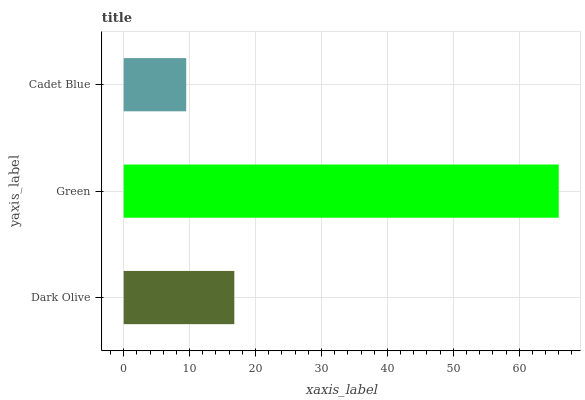Is Cadet Blue the minimum?
Answer yes or no. Yes. Is Green the maximum?
Answer yes or no. Yes. Is Green the minimum?
Answer yes or no. No. Is Cadet Blue the maximum?
Answer yes or no. No. Is Green greater than Cadet Blue?
Answer yes or no. Yes. Is Cadet Blue less than Green?
Answer yes or no. Yes. Is Cadet Blue greater than Green?
Answer yes or no. No. Is Green less than Cadet Blue?
Answer yes or no. No. Is Dark Olive the high median?
Answer yes or no. Yes. Is Dark Olive the low median?
Answer yes or no. Yes. Is Green the high median?
Answer yes or no. No. Is Green the low median?
Answer yes or no. No. 